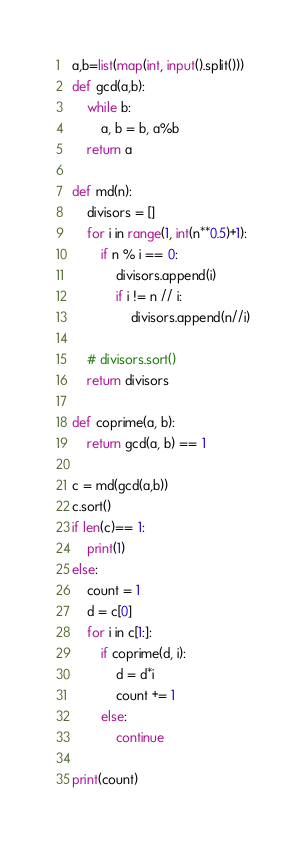<code> <loc_0><loc_0><loc_500><loc_500><_Python_>a,b=list(map(int, input().split()))
def gcd(a,b):
    while b:
        a, b = b, a%b
    return a

def md(n):
    divisors = []
    for i in range(1, int(n**0.5)+1):
        if n % i == 0:
            divisors.append(i)
            if i != n // i:
                divisors.append(n//i)

    # divisors.sort()
    return divisors

def coprime(a, b):
    return gcd(a, b) == 1

c = md(gcd(a,b))
c.sort()
if len(c)== 1:
    print(1)
else:
    count = 1
    d = c[0]
    for i in c[1:]:
        if coprime(d, i):
            d = d*i
            count += 1
        else:
            continue

print(count)</code> 